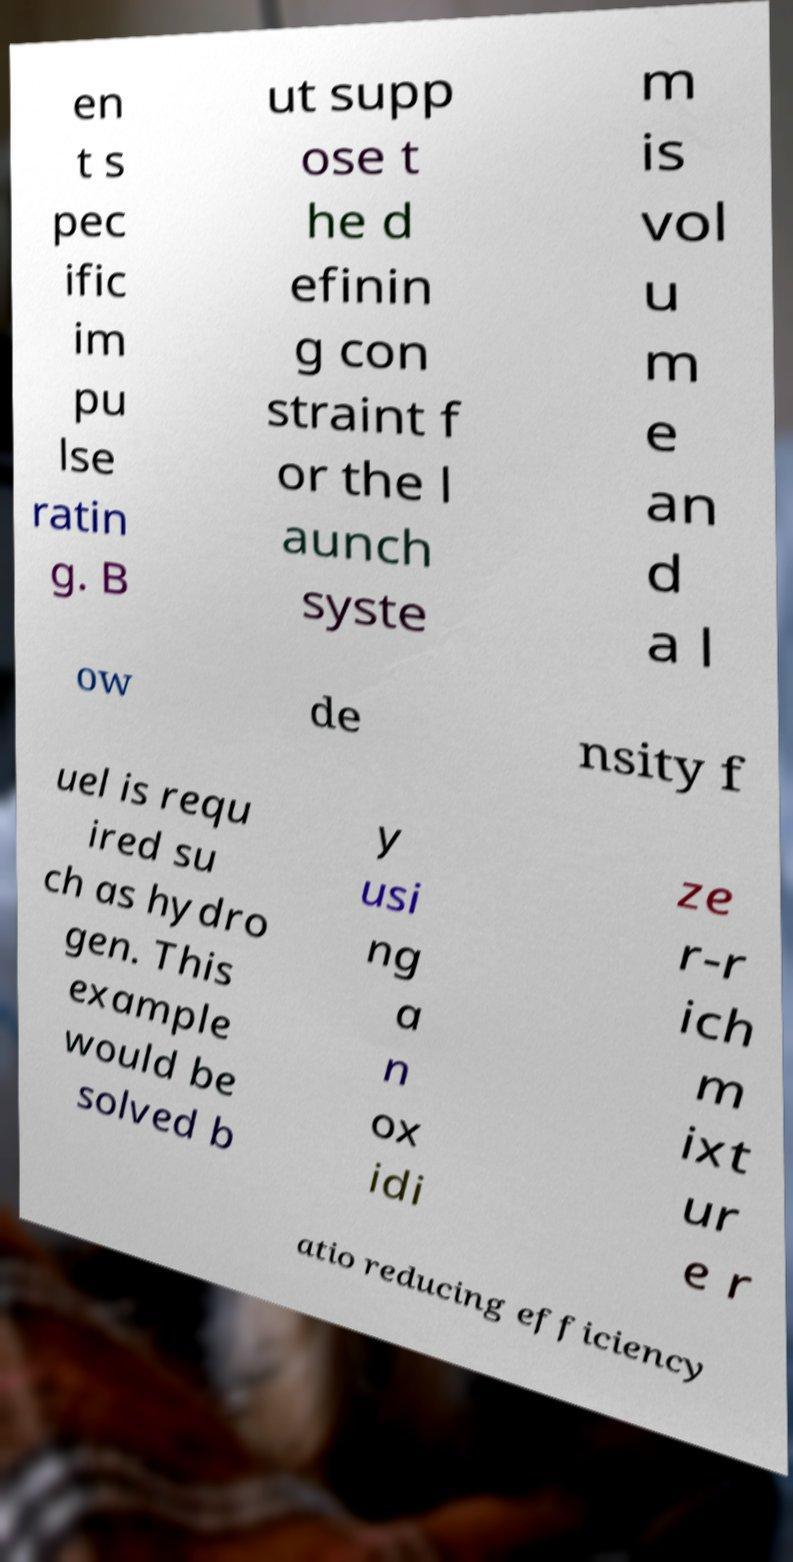Could you assist in decoding the text presented in this image and type it out clearly? en t s pec ific im pu lse ratin g. B ut supp ose t he d efinin g con straint f or the l aunch syste m is vol u m e an d a l ow de nsity f uel is requ ired su ch as hydro gen. This example would be solved b y usi ng a n ox idi ze r-r ich m ixt ur e r atio reducing efficiency 